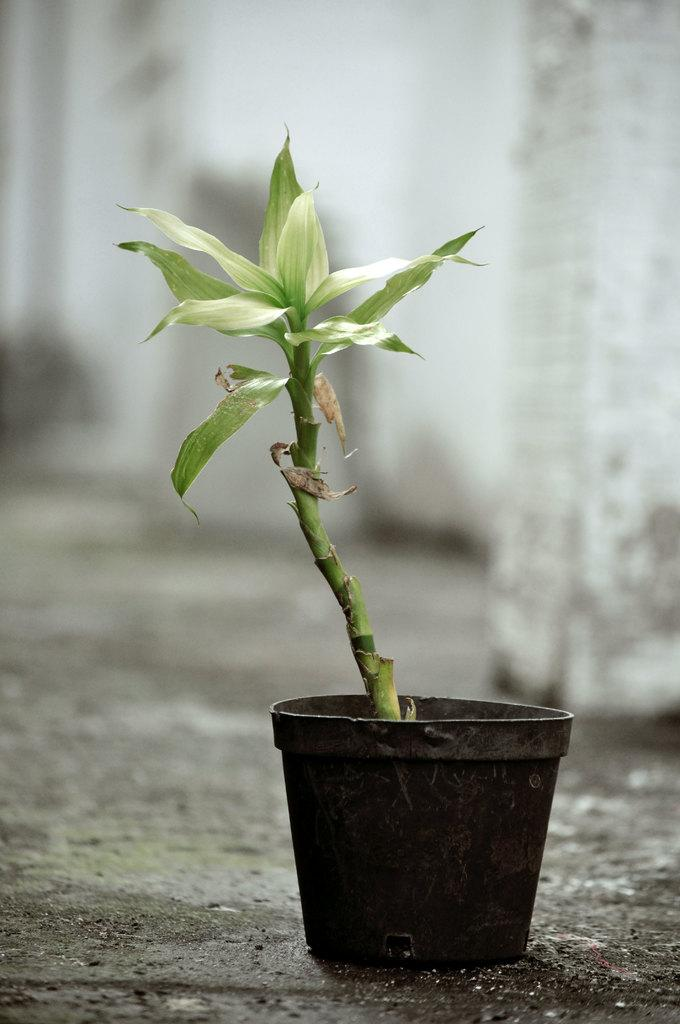What object is present on the ground in the image? There is a flower pot in the image. Can you describe the location of the flower pot? The flower pot is on the ground. How many ants can be seen crawling on the flower pot in the image? There are no ants visible on the flower pot in the image. Is the yard around the flower pot wet due to rain in the image? There is no indication of rain or a wet yard in the image. 